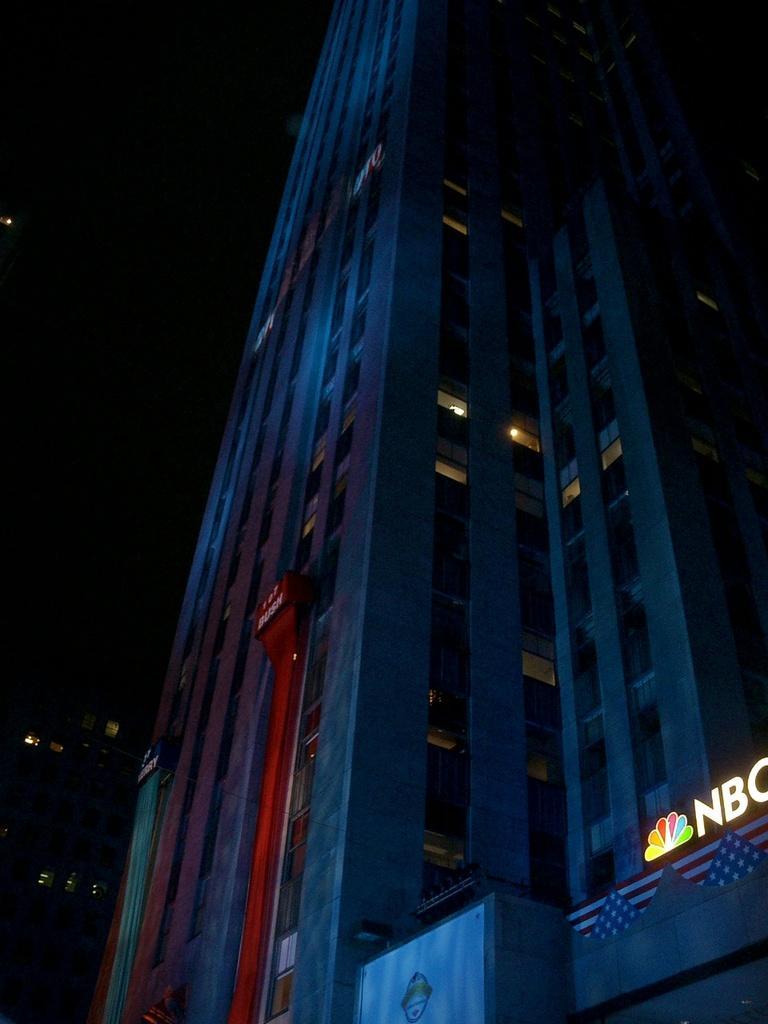Could you give a brief overview of what you see in this image? This image consists of a skyscraper along with windows. On which we can see a text. The background is too dark. 